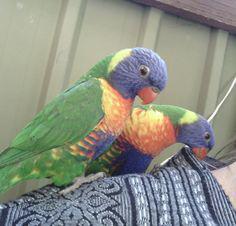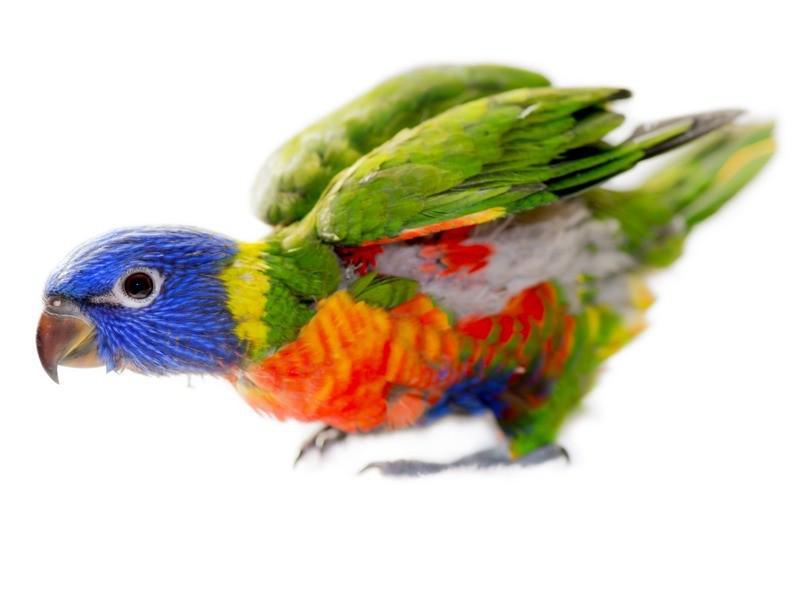The first image is the image on the left, the second image is the image on the right. Given the left and right images, does the statement "One image features two multicolored parrots side-by-side." hold true? Answer yes or no. Yes. The first image is the image on the left, the second image is the image on the right. Assess this claim about the two images: "In one of the images there are two colorful birds standing next to each other.". Correct or not? Answer yes or no. Yes. 